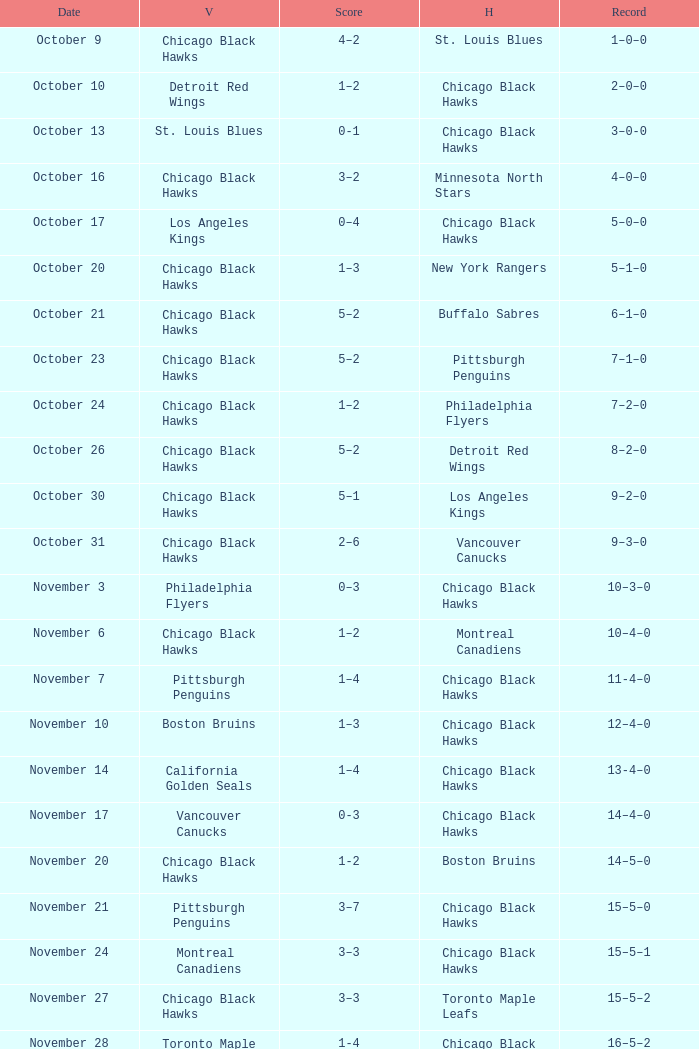What is the Score of the Chicago Black Hawks Home game with the Visiting Vancouver Canucks on November 17? 0-3. 